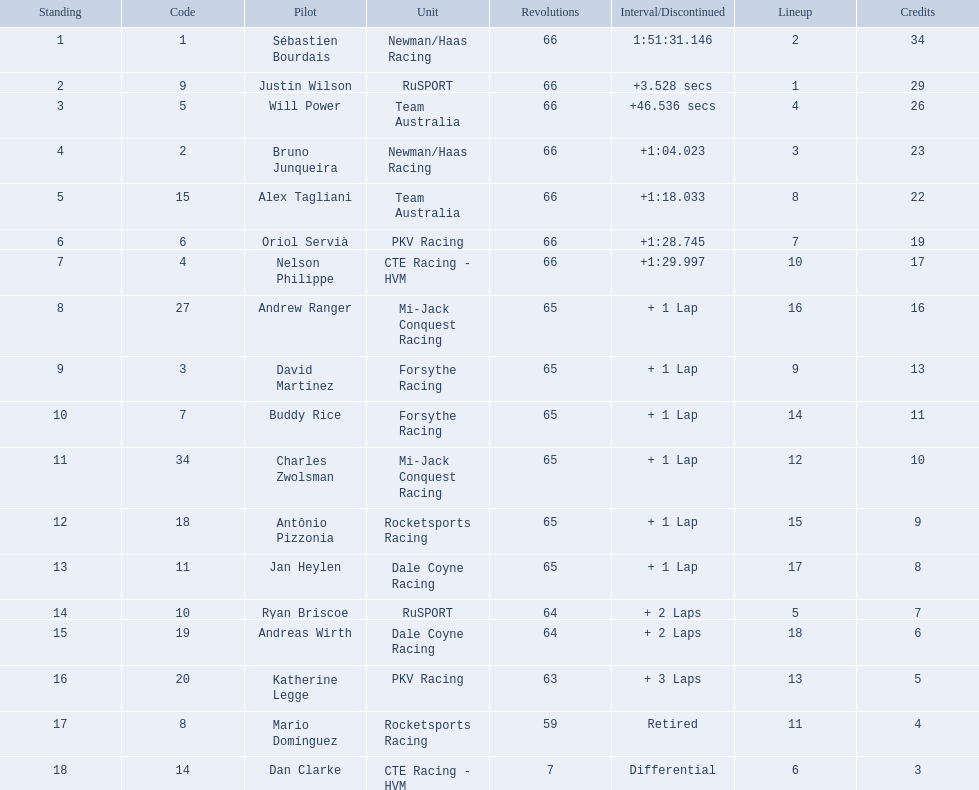What are the names of the drivers who were in position 14 through position 18? Ryan Briscoe, Andreas Wirth, Katherine Legge, Mario Domínguez, Dan Clarke. Of these , which ones didn't finish due to retired or differential? Mario Domínguez, Dan Clarke. Which one of the previous drivers retired? Mario Domínguez. Which of the drivers in question 2 had a differential? Dan Clarke. Parse the full table in json format. {'header': ['Standing', 'Code', 'Pilot', 'Unit', 'Revolutions', 'Interval/Discontinued', 'Lineup', 'Credits'], 'rows': [['1', '1', 'Sébastien Bourdais', 'Newman/Haas Racing', '66', '1:51:31.146', '2', '34'], ['2', '9', 'Justin Wilson', 'RuSPORT', '66', '+3.528 secs', '1', '29'], ['3', '5', 'Will Power', 'Team Australia', '66', '+46.536 secs', '4', '26'], ['4', '2', 'Bruno Junqueira', 'Newman/Haas Racing', '66', '+1:04.023', '3', '23'], ['5', '15', 'Alex Tagliani', 'Team Australia', '66', '+1:18.033', '8', '22'], ['6', '6', 'Oriol Servià', 'PKV Racing', '66', '+1:28.745', '7', '19'], ['7', '4', 'Nelson Philippe', 'CTE Racing - HVM', '66', '+1:29.997', '10', '17'], ['8', '27', 'Andrew Ranger', 'Mi-Jack Conquest Racing', '65', '+ 1 Lap', '16', '16'], ['9', '3', 'David Martínez', 'Forsythe Racing', '65', '+ 1 Lap', '9', '13'], ['10', '7', 'Buddy Rice', 'Forsythe Racing', '65', '+ 1 Lap', '14', '11'], ['11', '34', 'Charles Zwolsman', 'Mi-Jack Conquest Racing', '65', '+ 1 Lap', '12', '10'], ['12', '18', 'Antônio Pizzonia', 'Rocketsports Racing', '65', '+ 1 Lap', '15', '9'], ['13', '11', 'Jan Heylen', 'Dale Coyne Racing', '65', '+ 1 Lap', '17', '8'], ['14', '10', 'Ryan Briscoe', 'RuSPORT', '64', '+ 2 Laps', '5', '7'], ['15', '19', 'Andreas Wirth', 'Dale Coyne Racing', '64', '+ 2 Laps', '18', '6'], ['16', '20', 'Katherine Legge', 'PKV Racing', '63', '+ 3 Laps', '13', '5'], ['17', '8', 'Mario Domínguez', 'Rocketsports Racing', '59', 'Retired', '11', '4'], ['18', '14', 'Dan Clarke', 'CTE Racing - HVM', '7', 'Differential', '6', '3']]} What drivers started in the top 10? Sébastien Bourdais, Justin Wilson, Will Power, Bruno Junqueira, Alex Tagliani, Oriol Servià, Nelson Philippe, Ryan Briscoe, Dan Clarke. Which of those drivers completed all 66 laps? Sébastien Bourdais, Justin Wilson, Will Power, Bruno Junqueira, Alex Tagliani, Oriol Servià, Nelson Philippe. Whom of these did not drive for team australia? Sébastien Bourdais, Justin Wilson, Bruno Junqueira, Oriol Servià, Nelson Philippe. Which of these drivers finished more then a minuet after the winner? Bruno Junqueira, Oriol Servià, Nelson Philippe. Which of these drivers had the highest car number? Oriol Servià. 